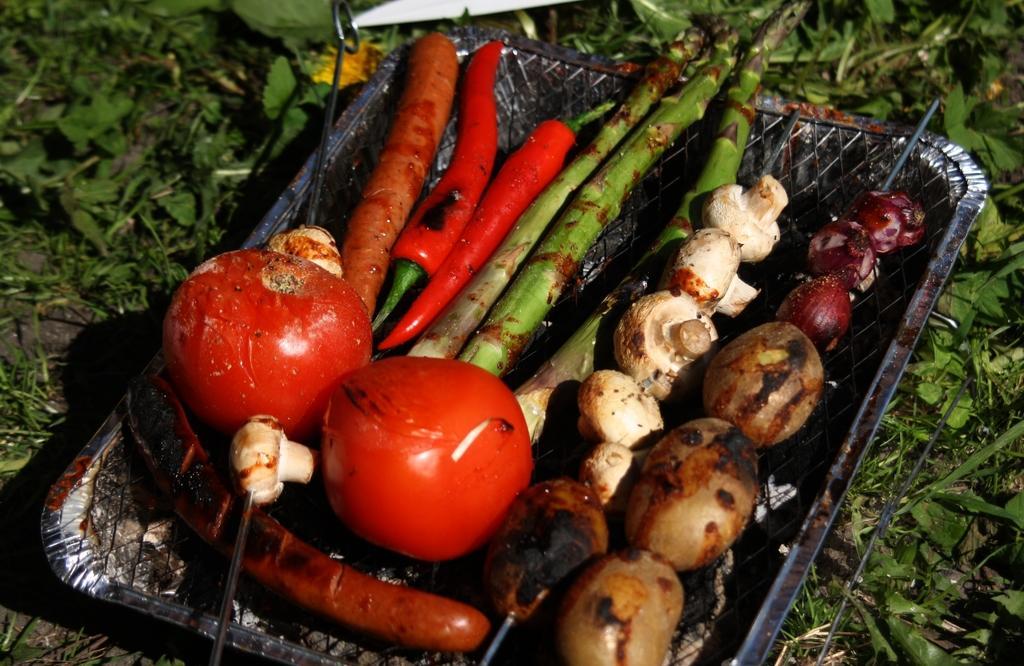Please provide a concise description of this image. In the image there are different vegetables kept on a grilling pad and around the vegetables there is a grass. 